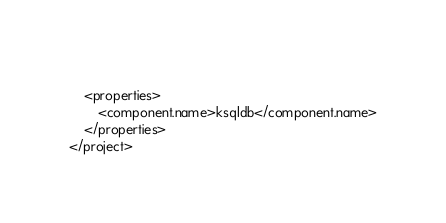<code> <loc_0><loc_0><loc_500><loc_500><_XML_>    
    <properties>
        <component.name>ksqldb</component.name>
    </properties>
</project>
</code> 